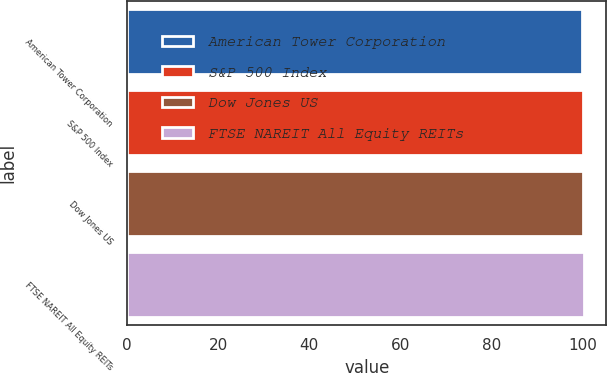Convert chart to OTSL. <chart><loc_0><loc_0><loc_500><loc_500><bar_chart><fcel>American Tower Corporation<fcel>S&P 500 Index<fcel>Dow Jones US<fcel>FTSE NAREIT All Equity REITs<nl><fcel>100<fcel>100.1<fcel>100.2<fcel>100.3<nl></chart> 